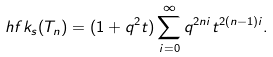<formula> <loc_0><loc_0><loc_500><loc_500>\ h f k _ { s } ( T _ { n } ) = ( 1 + q ^ { 2 } t ) \sum _ { i = 0 } ^ { \infty } q ^ { 2 n i } t ^ { 2 ( n - 1 ) i } .</formula> 